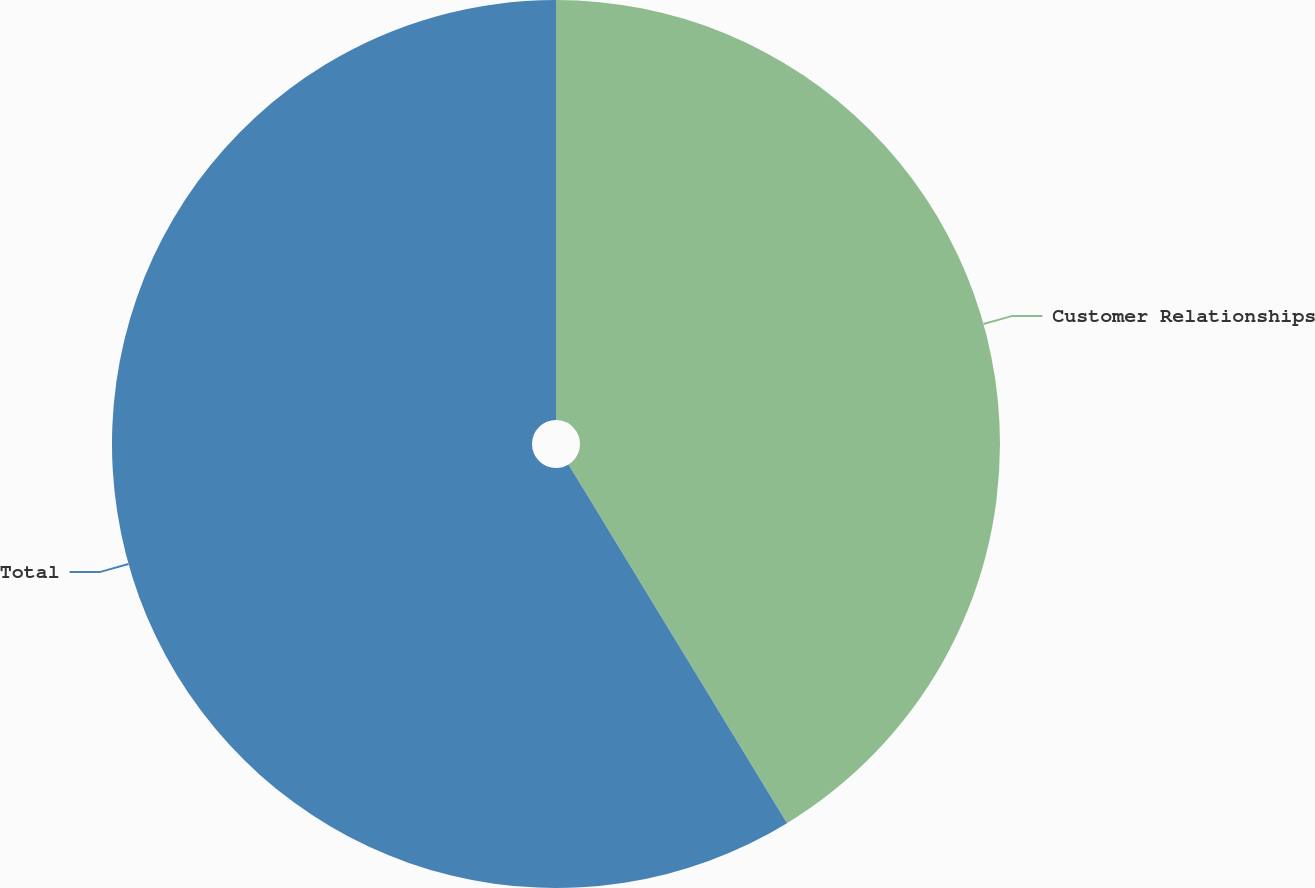Convert chart. <chart><loc_0><loc_0><loc_500><loc_500><pie_chart><fcel>Customer Relationships<fcel>Total<nl><fcel>41.29%<fcel>58.71%<nl></chart> 